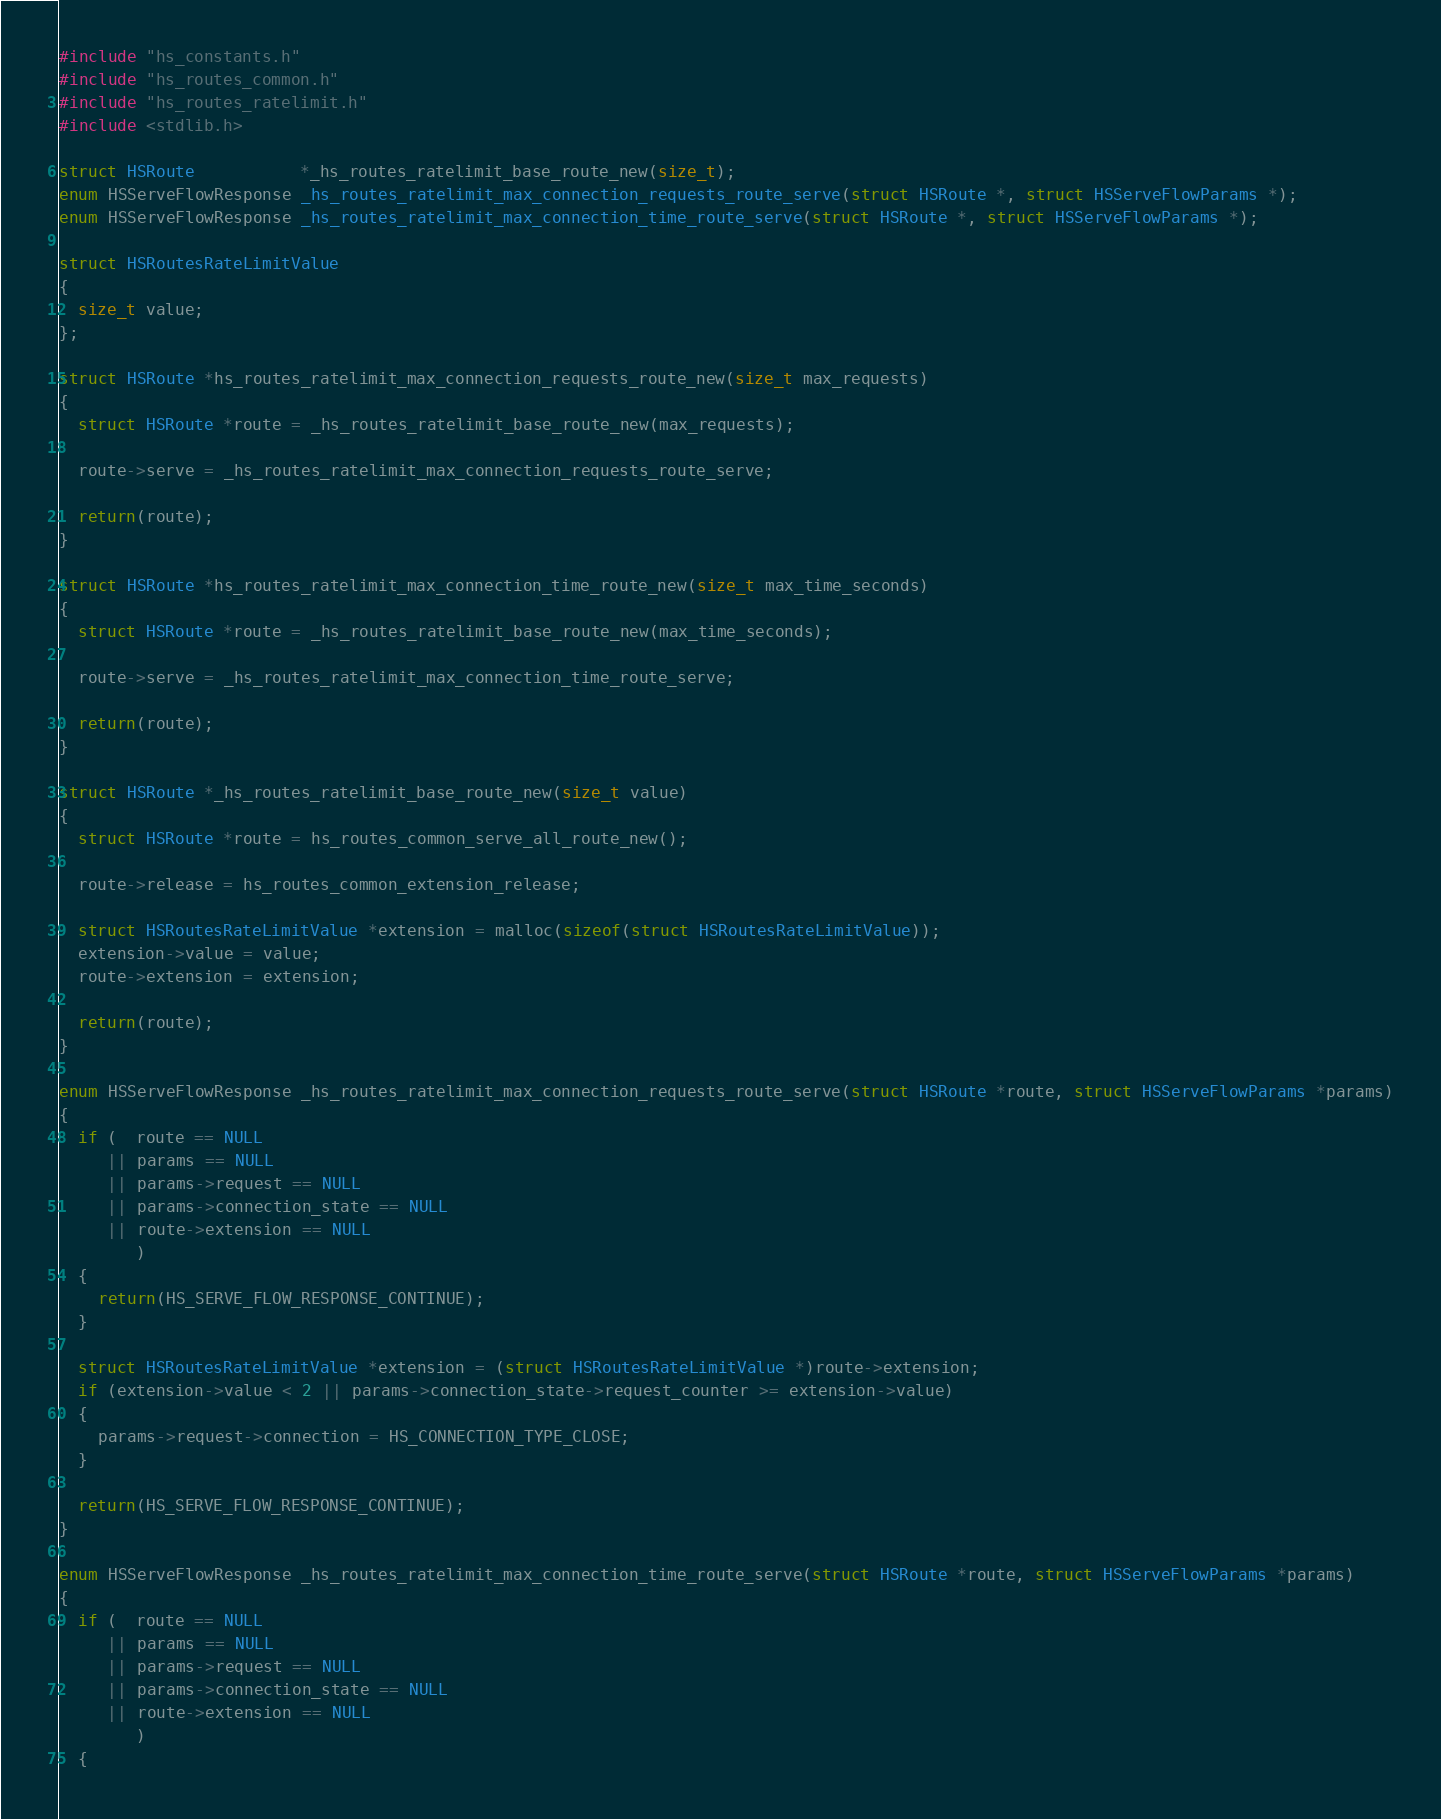Convert code to text. <code><loc_0><loc_0><loc_500><loc_500><_C_>#include "hs_constants.h"
#include "hs_routes_common.h"
#include "hs_routes_ratelimit.h"
#include <stdlib.h>

struct HSRoute           *_hs_routes_ratelimit_base_route_new(size_t);
enum HSServeFlowResponse _hs_routes_ratelimit_max_connection_requests_route_serve(struct HSRoute *, struct HSServeFlowParams *);
enum HSServeFlowResponse _hs_routes_ratelimit_max_connection_time_route_serve(struct HSRoute *, struct HSServeFlowParams *);

struct HSRoutesRateLimitValue
{
  size_t value;
};

struct HSRoute *hs_routes_ratelimit_max_connection_requests_route_new(size_t max_requests)
{
  struct HSRoute *route = _hs_routes_ratelimit_base_route_new(max_requests);

  route->serve = _hs_routes_ratelimit_max_connection_requests_route_serve;

  return(route);
}

struct HSRoute *hs_routes_ratelimit_max_connection_time_route_new(size_t max_time_seconds)
{
  struct HSRoute *route = _hs_routes_ratelimit_base_route_new(max_time_seconds);

  route->serve = _hs_routes_ratelimit_max_connection_time_route_serve;

  return(route);
}

struct HSRoute *_hs_routes_ratelimit_base_route_new(size_t value)
{
  struct HSRoute *route = hs_routes_common_serve_all_route_new();

  route->release = hs_routes_common_extension_release;

  struct HSRoutesRateLimitValue *extension = malloc(sizeof(struct HSRoutesRateLimitValue));
  extension->value = value;
  route->extension = extension;

  return(route);
}

enum HSServeFlowResponse _hs_routes_ratelimit_max_connection_requests_route_serve(struct HSRoute *route, struct HSServeFlowParams *params)
{
  if (  route == NULL
     || params == NULL
     || params->request == NULL
     || params->connection_state == NULL
     || route->extension == NULL
        )
  {
    return(HS_SERVE_FLOW_RESPONSE_CONTINUE);
  }

  struct HSRoutesRateLimitValue *extension = (struct HSRoutesRateLimitValue *)route->extension;
  if (extension->value < 2 || params->connection_state->request_counter >= extension->value)
  {
    params->request->connection = HS_CONNECTION_TYPE_CLOSE;
  }

  return(HS_SERVE_FLOW_RESPONSE_CONTINUE);
}

enum HSServeFlowResponse _hs_routes_ratelimit_max_connection_time_route_serve(struct HSRoute *route, struct HSServeFlowParams *params)
{
  if (  route == NULL
     || params == NULL
     || params->request == NULL
     || params->connection_state == NULL
     || route->extension == NULL
        )
  {</code> 